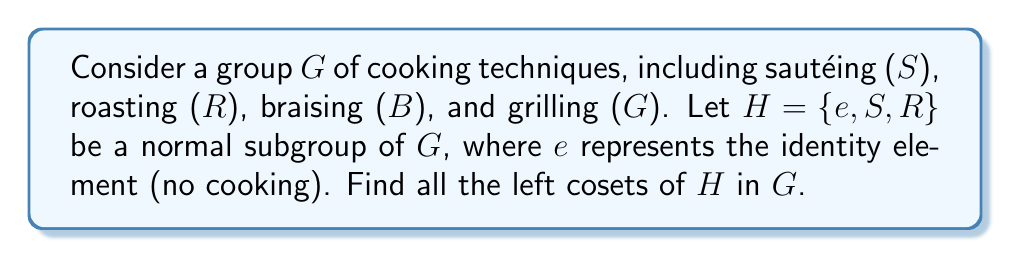What is the answer to this math problem? To find the left cosets of $H$ in $G$, we need to follow these steps:

1. First, let's list all the elements of group $G$:
   $G = \{e, S, R, B, G\}$

2. We're given that $H = \{e, S, R\}$ is a normal subgroup of $G$.

3. To find the left cosets, we multiply each element of $G$ by $H$ from the left:

   a) $eH = \{e \cdot e, e \cdot S, e \cdot R\} = \{e, S, R\} = H$
   
   b) $SH = \{S \cdot e, S \cdot S, S \cdot R\} = \{S, e, R\} = H$
   
   c) $RH = \{R \cdot e, R \cdot S, R \cdot R\} = \{R, S, e\} = H$
   
   d) $BH = \{B \cdot e, B \cdot S, B \cdot R\} = \{B, BS, BR\}$
   
   e) $GH = \{G \cdot e, G \cdot S, G \cdot R\} = \{G, GS, GR\}$

4. We can see that $eH = SH = RH = H$, while $BH$ and $GH$ are distinct cosets.

5. Since $H$ is a normal subgroup, the left cosets are equal to the right cosets. Therefore, we don't need to calculate right cosets separately.

6. The distinct cosets are $H$, $BH$, and $GH$.

In cooking terms, this means that sautéing and roasting can be interchanged with doing nothing (the identity element) without changing the coset, while braising and grilling each create their own distinct groups of techniques when combined with the elements of $H$.
Answer: The left cosets of $H$ in $G$ are:
$$H = \{e, S, R\}$$
$$BH = \{B, BS, BR\}$$
$$GH = \{G, GS, GR\}$$ 